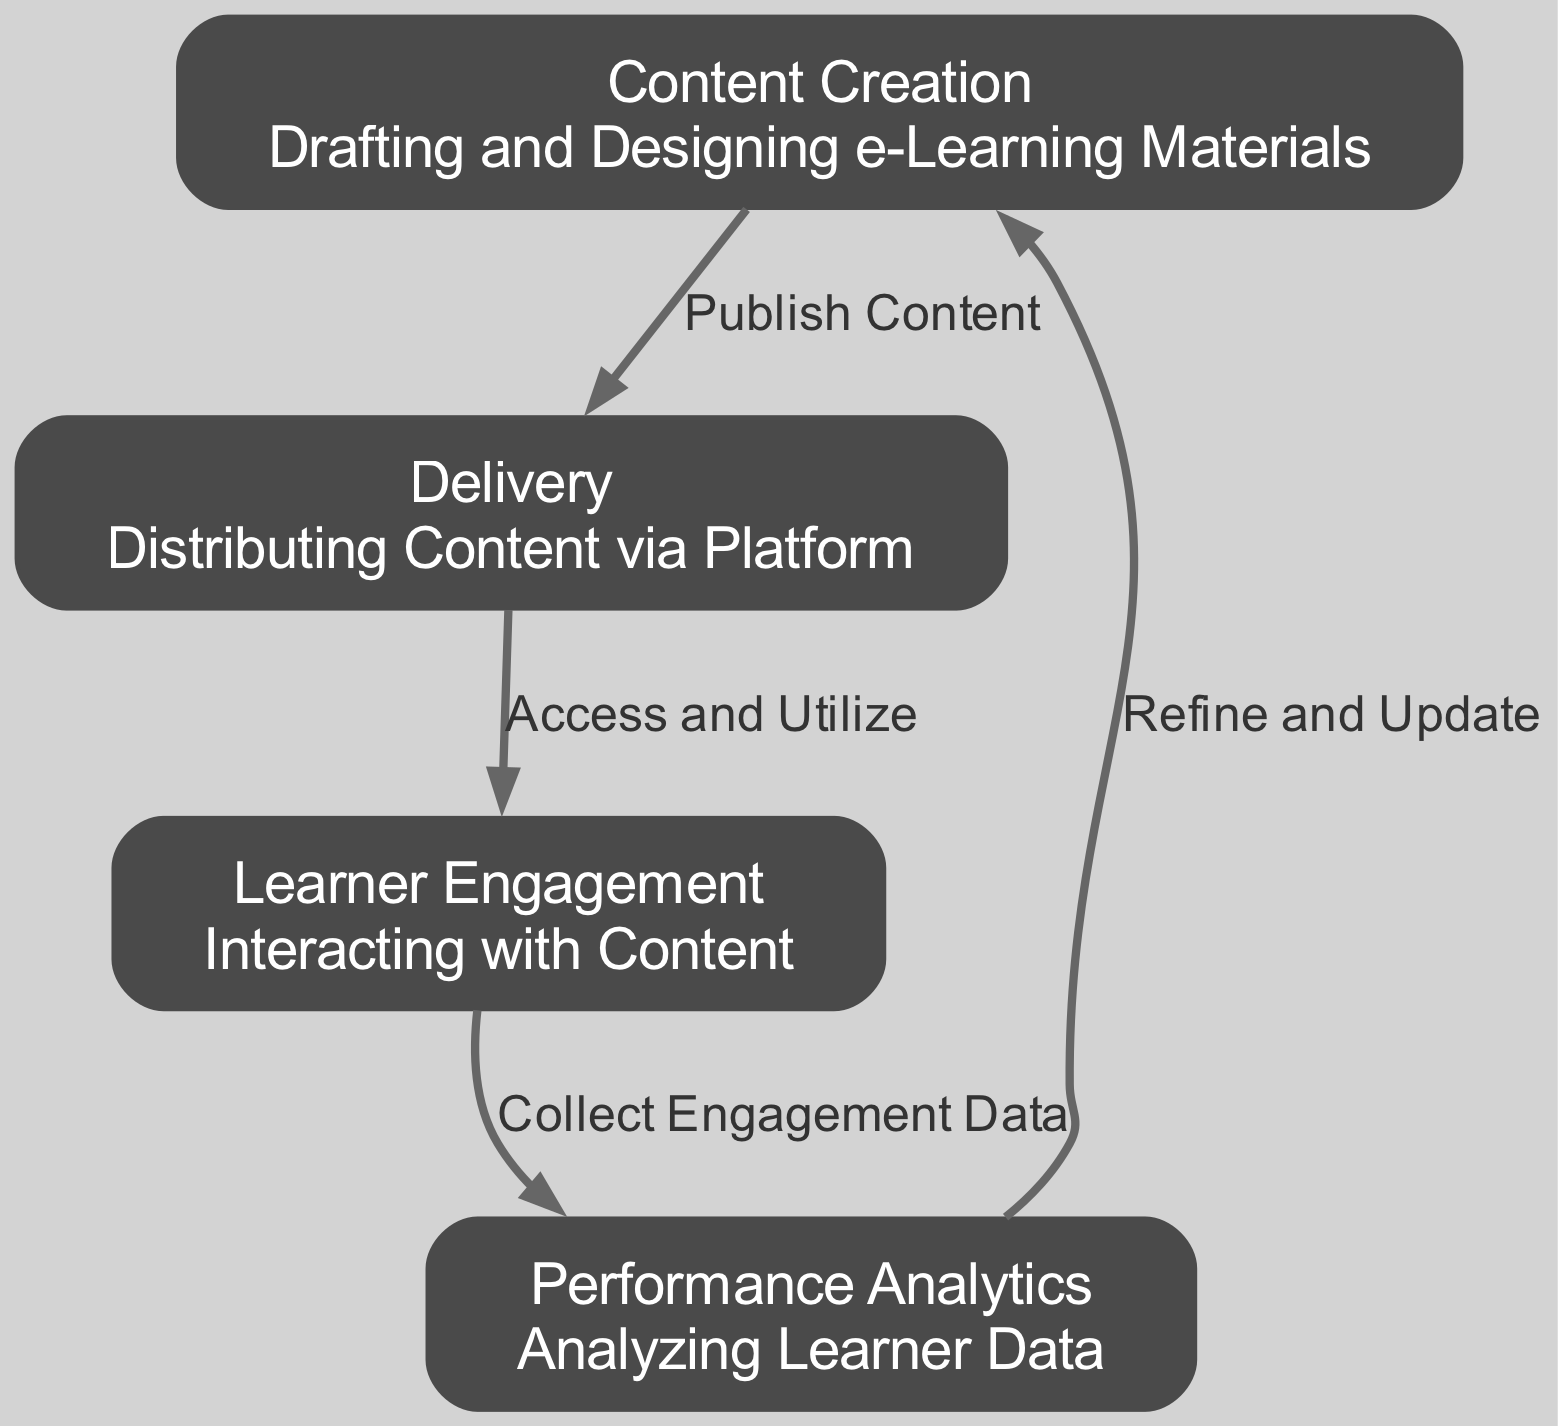What are the four nodes in the diagram? The diagram contains four nodes: Content Creation, Delivery, Learner Engagement, and Performance Analytics. These nodes represent key stages in the feedback loop of educational technology.
Answer: Content Creation, Delivery, Learner Engagement, Performance Analytics What is the relationship between Content Creation and Delivery? The edge connecting Content Creation to Delivery is labeled "Publish Content," indicating that the process of content creation leads directly to the content being delivered to learners.
Answer: Publish Content How many edges are there in the diagram? The diagram has four edges, each representing a transition from one node to another in the feedback loop of educational technology.
Answer: 4 What does the Learner Engagement node represent? The Learner Engagement node represents the stage where learners interact with the content provided on the platform. This phase is critical for effective learning and data collection.
Answer: Interacting with Content Which node collects data after the Learner Engagement? The Performance Analytics node collects engagement data after learners interact with the content, allowing for evaluations of learner performance and insights for content improvement.
Answer: Performance Analytics How does Performance Analytics connect to Content Creation? Performance Analytics connects back to Content Creation through the labeled edge "Refine and Update," indicating that the analytics gathered can inform necessary revisions to the educational content.
Answer: Refine and Update What is the main purpose of the Feedback Loop in Educational Technology? The overall purpose of the Feedback Loop is to create a dynamic cycle that enhances educational effectiveness by continuously refining content based on learner engagement and performance analysis, ensuring improved learning outcomes.
Answer: Enhance educational effectiveness Which node depicts the process of distributing content? The Delivery node depicts the process of distributing content to learners, signifying the transition from content creation to actual use by students.
Answer: Delivery What is analyzed in the Performance Analytics stage? In the Performance Analytics stage, learner data is analyzed to evaluate engagement and performance, which can be used to refine future content creation.
Answer: Learner Data 